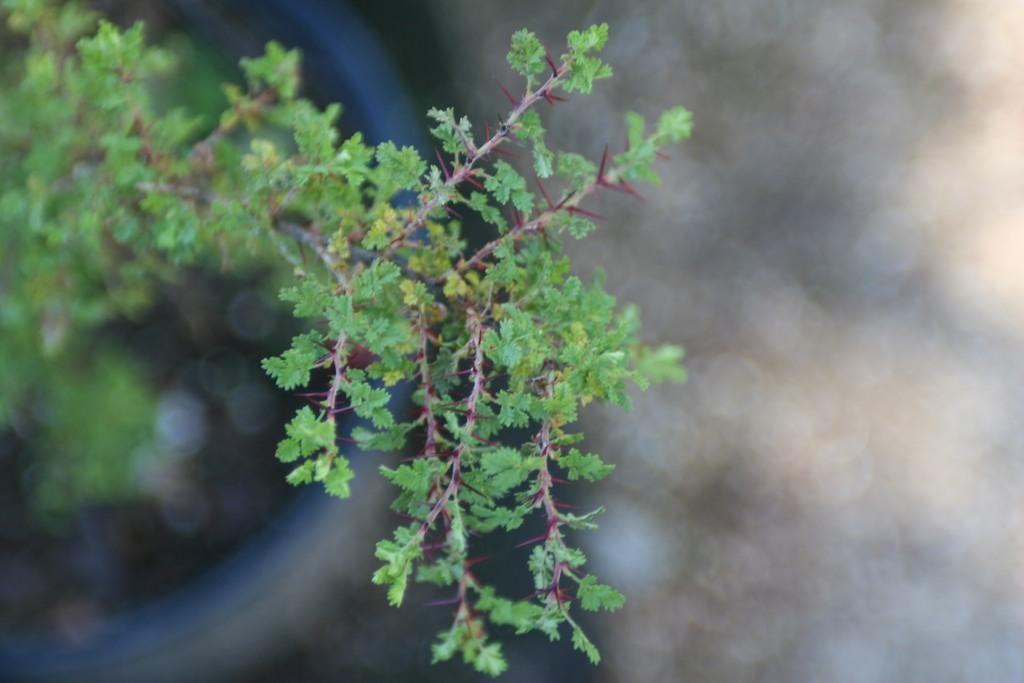What type of vegetation can be seen in the image? There are leaves in the image. What part of a plant is visible in the image? There are branches of a plant in the image. How many women are visible in the image? There are no women present in the image; it features leaves and branches of a plant. What type of stone can be seen in the image? There is no stone present in the image; it features leaves and branches of a plant. 